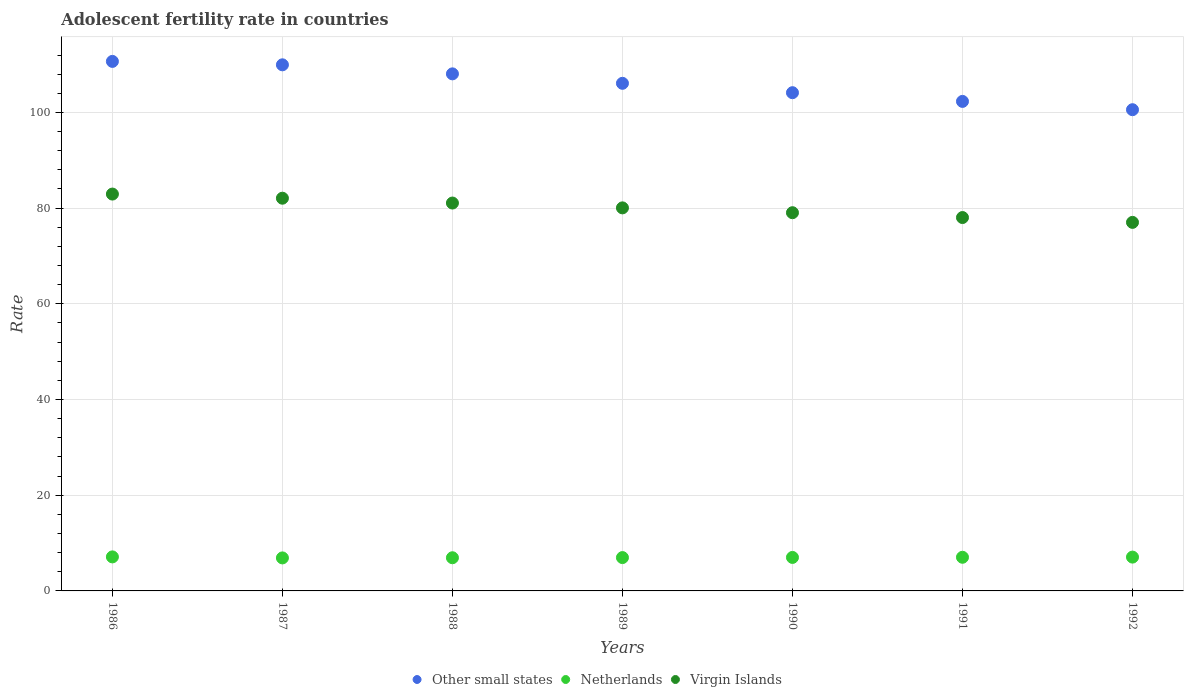How many different coloured dotlines are there?
Offer a very short reply. 3. What is the adolescent fertility rate in Netherlands in 1986?
Your answer should be compact. 7.11. Across all years, what is the maximum adolescent fertility rate in Other small states?
Offer a very short reply. 110.66. Across all years, what is the minimum adolescent fertility rate in Other small states?
Provide a short and direct response. 100.57. In which year was the adolescent fertility rate in Netherlands maximum?
Your answer should be very brief. 1986. What is the total adolescent fertility rate in Netherlands in the graph?
Provide a succinct answer. 49.01. What is the difference between the adolescent fertility rate in Netherlands in 1991 and that in 1992?
Offer a terse response. -0.03. What is the difference between the adolescent fertility rate in Other small states in 1991 and the adolescent fertility rate in Netherlands in 1986?
Your answer should be very brief. 95.19. What is the average adolescent fertility rate in Other small states per year?
Your answer should be very brief. 105.97. In the year 1991, what is the difference between the adolescent fertility rate in Virgin Islands and adolescent fertility rate in Other small states?
Keep it short and to the point. -24.27. What is the ratio of the adolescent fertility rate in Netherlands in 1986 to that in 1991?
Make the answer very short. 1.01. Is the adolescent fertility rate in Other small states in 1986 less than that in 1989?
Ensure brevity in your answer.  No. Is the difference between the adolescent fertility rate in Virgin Islands in 1987 and 1992 greater than the difference between the adolescent fertility rate in Other small states in 1987 and 1992?
Provide a short and direct response. No. What is the difference between the highest and the second highest adolescent fertility rate in Virgin Islands?
Offer a very short reply. 0.86. What is the difference between the highest and the lowest adolescent fertility rate in Virgin Islands?
Ensure brevity in your answer.  5.92. Is the sum of the adolescent fertility rate in Netherlands in 1988 and 1989 greater than the maximum adolescent fertility rate in Other small states across all years?
Keep it short and to the point. No. Is it the case that in every year, the sum of the adolescent fertility rate in Other small states and adolescent fertility rate in Virgin Islands  is greater than the adolescent fertility rate in Netherlands?
Give a very brief answer. Yes. Is the adolescent fertility rate in Netherlands strictly greater than the adolescent fertility rate in Other small states over the years?
Offer a very short reply. No. Is the adolescent fertility rate in Virgin Islands strictly less than the adolescent fertility rate in Netherlands over the years?
Provide a short and direct response. No. How many dotlines are there?
Offer a terse response. 3. How many years are there in the graph?
Your answer should be compact. 7. What is the difference between two consecutive major ticks on the Y-axis?
Offer a terse response. 20. Does the graph contain any zero values?
Your answer should be very brief. No. Does the graph contain grids?
Your answer should be very brief. Yes. How many legend labels are there?
Provide a succinct answer. 3. What is the title of the graph?
Your response must be concise. Adolescent fertility rate in countries. What is the label or title of the X-axis?
Give a very brief answer. Years. What is the label or title of the Y-axis?
Make the answer very short. Rate. What is the Rate in Other small states in 1986?
Your answer should be compact. 110.66. What is the Rate in Netherlands in 1986?
Provide a short and direct response. 7.11. What is the Rate in Virgin Islands in 1986?
Make the answer very short. 82.94. What is the Rate of Other small states in 1987?
Make the answer very short. 109.95. What is the Rate of Netherlands in 1987?
Your answer should be compact. 6.9. What is the Rate of Virgin Islands in 1987?
Make the answer very short. 82.07. What is the Rate in Other small states in 1988?
Keep it short and to the point. 108.06. What is the Rate in Netherlands in 1988?
Your answer should be compact. 6.93. What is the Rate of Virgin Islands in 1988?
Provide a short and direct response. 81.06. What is the Rate in Other small states in 1989?
Keep it short and to the point. 106.08. What is the Rate in Netherlands in 1989?
Offer a terse response. 6.97. What is the Rate of Virgin Islands in 1989?
Ensure brevity in your answer.  80.05. What is the Rate of Other small states in 1990?
Make the answer very short. 104.12. What is the Rate of Netherlands in 1990?
Your answer should be very brief. 7. What is the Rate of Virgin Islands in 1990?
Ensure brevity in your answer.  79.04. What is the Rate in Other small states in 1991?
Your answer should be very brief. 102.3. What is the Rate in Netherlands in 1991?
Your answer should be compact. 7.03. What is the Rate in Virgin Islands in 1991?
Keep it short and to the point. 78.03. What is the Rate of Other small states in 1992?
Provide a succinct answer. 100.57. What is the Rate of Netherlands in 1992?
Offer a terse response. 7.07. What is the Rate of Virgin Islands in 1992?
Offer a terse response. 77.02. Across all years, what is the maximum Rate in Other small states?
Your response must be concise. 110.66. Across all years, what is the maximum Rate in Netherlands?
Provide a short and direct response. 7.11. Across all years, what is the maximum Rate in Virgin Islands?
Give a very brief answer. 82.94. Across all years, what is the minimum Rate in Other small states?
Your answer should be compact. 100.57. Across all years, what is the minimum Rate of Netherlands?
Your answer should be compact. 6.9. Across all years, what is the minimum Rate of Virgin Islands?
Your answer should be compact. 77.02. What is the total Rate of Other small states in the graph?
Make the answer very short. 741.76. What is the total Rate in Netherlands in the graph?
Your answer should be compact. 49.01. What is the total Rate of Virgin Islands in the graph?
Give a very brief answer. 560.22. What is the difference between the Rate of Other small states in 1986 and that in 1987?
Provide a succinct answer. 0.71. What is the difference between the Rate of Netherlands in 1986 and that in 1987?
Your response must be concise. 0.21. What is the difference between the Rate in Virgin Islands in 1986 and that in 1987?
Make the answer very short. 0.86. What is the difference between the Rate in Other small states in 1986 and that in 1988?
Make the answer very short. 2.6. What is the difference between the Rate of Netherlands in 1986 and that in 1988?
Offer a very short reply. 0.18. What is the difference between the Rate in Virgin Islands in 1986 and that in 1988?
Your answer should be compact. 1.87. What is the difference between the Rate in Other small states in 1986 and that in 1989?
Offer a very short reply. 4.58. What is the difference between the Rate in Netherlands in 1986 and that in 1989?
Offer a very short reply. 0.14. What is the difference between the Rate in Virgin Islands in 1986 and that in 1989?
Provide a succinct answer. 2.89. What is the difference between the Rate of Other small states in 1986 and that in 1990?
Provide a succinct answer. 6.54. What is the difference between the Rate in Netherlands in 1986 and that in 1990?
Offer a very short reply. 0.11. What is the difference between the Rate in Virgin Islands in 1986 and that in 1990?
Offer a terse response. 3.9. What is the difference between the Rate of Other small states in 1986 and that in 1991?
Offer a terse response. 8.36. What is the difference between the Rate in Netherlands in 1986 and that in 1991?
Provide a succinct answer. 0.08. What is the difference between the Rate of Virgin Islands in 1986 and that in 1991?
Your response must be concise. 4.91. What is the difference between the Rate of Other small states in 1986 and that in 1992?
Provide a succinct answer. 10.09. What is the difference between the Rate in Netherlands in 1986 and that in 1992?
Your response must be concise. 0.04. What is the difference between the Rate in Virgin Islands in 1986 and that in 1992?
Give a very brief answer. 5.92. What is the difference between the Rate in Other small states in 1987 and that in 1988?
Your answer should be very brief. 1.89. What is the difference between the Rate in Netherlands in 1987 and that in 1988?
Offer a very short reply. -0.03. What is the difference between the Rate of Virgin Islands in 1987 and that in 1988?
Your answer should be compact. 1.01. What is the difference between the Rate of Other small states in 1987 and that in 1989?
Your answer should be compact. 3.87. What is the difference between the Rate of Netherlands in 1987 and that in 1989?
Ensure brevity in your answer.  -0.07. What is the difference between the Rate of Virgin Islands in 1987 and that in 1989?
Your answer should be compact. 2.02. What is the difference between the Rate in Other small states in 1987 and that in 1990?
Provide a succinct answer. 5.83. What is the difference between the Rate of Netherlands in 1987 and that in 1990?
Provide a succinct answer. -0.1. What is the difference between the Rate of Virgin Islands in 1987 and that in 1990?
Provide a short and direct response. 3.03. What is the difference between the Rate in Other small states in 1987 and that in 1991?
Ensure brevity in your answer.  7.65. What is the difference between the Rate in Netherlands in 1987 and that in 1991?
Give a very brief answer. -0.13. What is the difference between the Rate in Virgin Islands in 1987 and that in 1991?
Offer a very short reply. 4.04. What is the difference between the Rate of Other small states in 1987 and that in 1992?
Keep it short and to the point. 9.38. What is the difference between the Rate of Netherlands in 1987 and that in 1992?
Offer a terse response. -0.17. What is the difference between the Rate in Virgin Islands in 1987 and that in 1992?
Offer a terse response. 5.05. What is the difference between the Rate in Other small states in 1988 and that in 1989?
Give a very brief answer. 1.98. What is the difference between the Rate of Netherlands in 1988 and that in 1989?
Offer a very short reply. -0.03. What is the difference between the Rate of Virgin Islands in 1988 and that in 1989?
Your answer should be very brief. 1.01. What is the difference between the Rate in Other small states in 1988 and that in 1990?
Your answer should be very brief. 3.94. What is the difference between the Rate in Netherlands in 1988 and that in 1990?
Your answer should be very brief. -0.07. What is the difference between the Rate in Virgin Islands in 1988 and that in 1990?
Keep it short and to the point. 2.02. What is the difference between the Rate of Other small states in 1988 and that in 1991?
Your answer should be very brief. 5.76. What is the difference between the Rate in Netherlands in 1988 and that in 1991?
Give a very brief answer. -0.1. What is the difference between the Rate of Virgin Islands in 1988 and that in 1991?
Provide a succinct answer. 3.03. What is the difference between the Rate of Other small states in 1988 and that in 1992?
Give a very brief answer. 7.49. What is the difference between the Rate in Netherlands in 1988 and that in 1992?
Provide a short and direct response. -0.13. What is the difference between the Rate in Virgin Islands in 1988 and that in 1992?
Your answer should be very brief. 4.04. What is the difference between the Rate in Other small states in 1989 and that in 1990?
Keep it short and to the point. 1.96. What is the difference between the Rate in Netherlands in 1989 and that in 1990?
Provide a short and direct response. -0.03. What is the difference between the Rate of Virgin Islands in 1989 and that in 1990?
Provide a succinct answer. 1.01. What is the difference between the Rate in Other small states in 1989 and that in 1991?
Give a very brief answer. 3.78. What is the difference between the Rate of Netherlands in 1989 and that in 1991?
Provide a short and direct response. -0.07. What is the difference between the Rate of Virgin Islands in 1989 and that in 1991?
Keep it short and to the point. 2.02. What is the difference between the Rate in Other small states in 1989 and that in 1992?
Provide a short and direct response. 5.51. What is the difference between the Rate in Netherlands in 1989 and that in 1992?
Make the answer very short. -0.1. What is the difference between the Rate of Virgin Islands in 1989 and that in 1992?
Give a very brief answer. 3.03. What is the difference between the Rate of Other small states in 1990 and that in 1991?
Give a very brief answer. 1.82. What is the difference between the Rate in Netherlands in 1990 and that in 1991?
Offer a terse response. -0.03. What is the difference between the Rate in Virgin Islands in 1990 and that in 1991?
Your answer should be compact. 1.01. What is the difference between the Rate in Other small states in 1990 and that in 1992?
Provide a succinct answer. 3.55. What is the difference between the Rate in Netherlands in 1990 and that in 1992?
Offer a terse response. -0.07. What is the difference between the Rate of Virgin Islands in 1990 and that in 1992?
Provide a succinct answer. 2.02. What is the difference between the Rate in Other small states in 1991 and that in 1992?
Provide a succinct answer. 1.74. What is the difference between the Rate of Netherlands in 1991 and that in 1992?
Make the answer very short. -0.03. What is the difference between the Rate of Virgin Islands in 1991 and that in 1992?
Provide a short and direct response. 1.01. What is the difference between the Rate in Other small states in 1986 and the Rate in Netherlands in 1987?
Your answer should be compact. 103.76. What is the difference between the Rate of Other small states in 1986 and the Rate of Virgin Islands in 1987?
Provide a short and direct response. 28.59. What is the difference between the Rate in Netherlands in 1986 and the Rate in Virgin Islands in 1987?
Provide a succinct answer. -74.96. What is the difference between the Rate in Other small states in 1986 and the Rate in Netherlands in 1988?
Provide a succinct answer. 103.73. What is the difference between the Rate in Other small states in 1986 and the Rate in Virgin Islands in 1988?
Your answer should be very brief. 29.6. What is the difference between the Rate in Netherlands in 1986 and the Rate in Virgin Islands in 1988?
Your answer should be compact. -73.95. What is the difference between the Rate in Other small states in 1986 and the Rate in Netherlands in 1989?
Give a very brief answer. 103.7. What is the difference between the Rate of Other small states in 1986 and the Rate of Virgin Islands in 1989?
Your answer should be compact. 30.61. What is the difference between the Rate of Netherlands in 1986 and the Rate of Virgin Islands in 1989?
Your answer should be very brief. -72.94. What is the difference between the Rate in Other small states in 1986 and the Rate in Netherlands in 1990?
Provide a succinct answer. 103.66. What is the difference between the Rate of Other small states in 1986 and the Rate of Virgin Islands in 1990?
Give a very brief answer. 31.62. What is the difference between the Rate of Netherlands in 1986 and the Rate of Virgin Islands in 1990?
Keep it short and to the point. -71.93. What is the difference between the Rate in Other small states in 1986 and the Rate in Netherlands in 1991?
Ensure brevity in your answer.  103.63. What is the difference between the Rate in Other small states in 1986 and the Rate in Virgin Islands in 1991?
Ensure brevity in your answer.  32.63. What is the difference between the Rate of Netherlands in 1986 and the Rate of Virgin Islands in 1991?
Offer a terse response. -70.92. What is the difference between the Rate of Other small states in 1986 and the Rate of Netherlands in 1992?
Make the answer very short. 103.6. What is the difference between the Rate in Other small states in 1986 and the Rate in Virgin Islands in 1992?
Offer a terse response. 33.64. What is the difference between the Rate in Netherlands in 1986 and the Rate in Virgin Islands in 1992?
Provide a short and direct response. -69.91. What is the difference between the Rate in Other small states in 1987 and the Rate in Netherlands in 1988?
Your answer should be very brief. 103.02. What is the difference between the Rate in Other small states in 1987 and the Rate in Virgin Islands in 1988?
Provide a short and direct response. 28.89. What is the difference between the Rate of Netherlands in 1987 and the Rate of Virgin Islands in 1988?
Offer a very short reply. -74.16. What is the difference between the Rate of Other small states in 1987 and the Rate of Netherlands in 1989?
Provide a succinct answer. 102.98. What is the difference between the Rate in Other small states in 1987 and the Rate in Virgin Islands in 1989?
Offer a very short reply. 29.9. What is the difference between the Rate in Netherlands in 1987 and the Rate in Virgin Islands in 1989?
Offer a very short reply. -73.15. What is the difference between the Rate of Other small states in 1987 and the Rate of Netherlands in 1990?
Offer a very short reply. 102.95. What is the difference between the Rate of Other small states in 1987 and the Rate of Virgin Islands in 1990?
Ensure brevity in your answer.  30.91. What is the difference between the Rate in Netherlands in 1987 and the Rate in Virgin Islands in 1990?
Offer a terse response. -72.14. What is the difference between the Rate in Other small states in 1987 and the Rate in Netherlands in 1991?
Your answer should be very brief. 102.92. What is the difference between the Rate in Other small states in 1987 and the Rate in Virgin Islands in 1991?
Your response must be concise. 31.92. What is the difference between the Rate of Netherlands in 1987 and the Rate of Virgin Islands in 1991?
Your response must be concise. -71.13. What is the difference between the Rate in Other small states in 1987 and the Rate in Netherlands in 1992?
Your answer should be compact. 102.88. What is the difference between the Rate in Other small states in 1987 and the Rate in Virgin Islands in 1992?
Make the answer very short. 32.93. What is the difference between the Rate in Netherlands in 1987 and the Rate in Virgin Islands in 1992?
Provide a succinct answer. -70.12. What is the difference between the Rate of Other small states in 1988 and the Rate of Netherlands in 1989?
Your response must be concise. 101.09. What is the difference between the Rate of Other small states in 1988 and the Rate of Virgin Islands in 1989?
Your answer should be compact. 28.01. What is the difference between the Rate of Netherlands in 1988 and the Rate of Virgin Islands in 1989?
Your response must be concise. -73.12. What is the difference between the Rate of Other small states in 1988 and the Rate of Netherlands in 1990?
Your answer should be very brief. 101.06. What is the difference between the Rate of Other small states in 1988 and the Rate of Virgin Islands in 1990?
Your answer should be compact. 29.02. What is the difference between the Rate in Netherlands in 1988 and the Rate in Virgin Islands in 1990?
Your response must be concise. -72.11. What is the difference between the Rate in Other small states in 1988 and the Rate in Netherlands in 1991?
Provide a succinct answer. 101.03. What is the difference between the Rate of Other small states in 1988 and the Rate of Virgin Islands in 1991?
Your answer should be compact. 30.03. What is the difference between the Rate in Netherlands in 1988 and the Rate in Virgin Islands in 1991?
Your response must be concise. -71.1. What is the difference between the Rate in Other small states in 1988 and the Rate in Netherlands in 1992?
Ensure brevity in your answer.  100.99. What is the difference between the Rate in Other small states in 1988 and the Rate in Virgin Islands in 1992?
Offer a very short reply. 31.04. What is the difference between the Rate of Netherlands in 1988 and the Rate of Virgin Islands in 1992?
Provide a short and direct response. -70.09. What is the difference between the Rate in Other small states in 1989 and the Rate in Netherlands in 1990?
Give a very brief answer. 99.08. What is the difference between the Rate of Other small states in 1989 and the Rate of Virgin Islands in 1990?
Provide a succinct answer. 27.04. What is the difference between the Rate in Netherlands in 1989 and the Rate in Virgin Islands in 1990?
Ensure brevity in your answer.  -72.08. What is the difference between the Rate in Other small states in 1989 and the Rate in Netherlands in 1991?
Give a very brief answer. 99.05. What is the difference between the Rate in Other small states in 1989 and the Rate in Virgin Islands in 1991?
Your answer should be very brief. 28.05. What is the difference between the Rate in Netherlands in 1989 and the Rate in Virgin Islands in 1991?
Ensure brevity in your answer.  -71.07. What is the difference between the Rate of Other small states in 1989 and the Rate of Netherlands in 1992?
Your answer should be compact. 99.02. What is the difference between the Rate in Other small states in 1989 and the Rate in Virgin Islands in 1992?
Give a very brief answer. 29.06. What is the difference between the Rate in Netherlands in 1989 and the Rate in Virgin Islands in 1992?
Offer a very short reply. -70.05. What is the difference between the Rate in Other small states in 1990 and the Rate in Netherlands in 1991?
Offer a very short reply. 97.09. What is the difference between the Rate in Other small states in 1990 and the Rate in Virgin Islands in 1991?
Provide a short and direct response. 26.09. What is the difference between the Rate of Netherlands in 1990 and the Rate of Virgin Islands in 1991?
Provide a succinct answer. -71.03. What is the difference between the Rate in Other small states in 1990 and the Rate in Netherlands in 1992?
Your answer should be very brief. 97.06. What is the difference between the Rate of Other small states in 1990 and the Rate of Virgin Islands in 1992?
Offer a very short reply. 27.1. What is the difference between the Rate of Netherlands in 1990 and the Rate of Virgin Islands in 1992?
Offer a terse response. -70.02. What is the difference between the Rate of Other small states in 1991 and the Rate of Netherlands in 1992?
Give a very brief answer. 95.24. What is the difference between the Rate of Other small states in 1991 and the Rate of Virgin Islands in 1992?
Keep it short and to the point. 25.28. What is the difference between the Rate in Netherlands in 1991 and the Rate in Virgin Islands in 1992?
Your answer should be very brief. -69.99. What is the average Rate in Other small states per year?
Give a very brief answer. 105.97. What is the average Rate of Netherlands per year?
Your response must be concise. 7. What is the average Rate of Virgin Islands per year?
Provide a succinct answer. 80.03. In the year 1986, what is the difference between the Rate in Other small states and Rate in Netherlands?
Offer a very short reply. 103.55. In the year 1986, what is the difference between the Rate of Other small states and Rate of Virgin Islands?
Your response must be concise. 27.73. In the year 1986, what is the difference between the Rate of Netherlands and Rate of Virgin Islands?
Give a very brief answer. -75.83. In the year 1987, what is the difference between the Rate of Other small states and Rate of Netherlands?
Offer a terse response. 103.05. In the year 1987, what is the difference between the Rate of Other small states and Rate of Virgin Islands?
Offer a very short reply. 27.88. In the year 1987, what is the difference between the Rate in Netherlands and Rate in Virgin Islands?
Your answer should be very brief. -75.17. In the year 1988, what is the difference between the Rate in Other small states and Rate in Netherlands?
Keep it short and to the point. 101.13. In the year 1988, what is the difference between the Rate of Other small states and Rate of Virgin Islands?
Give a very brief answer. 27. In the year 1988, what is the difference between the Rate in Netherlands and Rate in Virgin Islands?
Your answer should be compact. -74.13. In the year 1989, what is the difference between the Rate in Other small states and Rate in Netherlands?
Your answer should be compact. 99.12. In the year 1989, what is the difference between the Rate in Other small states and Rate in Virgin Islands?
Your answer should be compact. 26.03. In the year 1989, what is the difference between the Rate of Netherlands and Rate of Virgin Islands?
Give a very brief answer. -73.09. In the year 1990, what is the difference between the Rate of Other small states and Rate of Netherlands?
Offer a terse response. 97.12. In the year 1990, what is the difference between the Rate in Other small states and Rate in Virgin Islands?
Ensure brevity in your answer.  25.08. In the year 1990, what is the difference between the Rate of Netherlands and Rate of Virgin Islands?
Your answer should be compact. -72.04. In the year 1991, what is the difference between the Rate of Other small states and Rate of Netherlands?
Provide a succinct answer. 95.27. In the year 1991, what is the difference between the Rate in Other small states and Rate in Virgin Islands?
Provide a short and direct response. 24.27. In the year 1991, what is the difference between the Rate in Netherlands and Rate in Virgin Islands?
Your answer should be compact. -71. In the year 1992, what is the difference between the Rate of Other small states and Rate of Netherlands?
Offer a very short reply. 93.5. In the year 1992, what is the difference between the Rate of Other small states and Rate of Virgin Islands?
Provide a succinct answer. 23.55. In the year 1992, what is the difference between the Rate in Netherlands and Rate in Virgin Islands?
Your response must be concise. -69.95. What is the ratio of the Rate of Other small states in 1986 to that in 1987?
Offer a terse response. 1.01. What is the ratio of the Rate in Netherlands in 1986 to that in 1987?
Give a very brief answer. 1.03. What is the ratio of the Rate in Virgin Islands in 1986 to that in 1987?
Make the answer very short. 1.01. What is the ratio of the Rate of Other small states in 1986 to that in 1988?
Offer a terse response. 1.02. What is the ratio of the Rate of Netherlands in 1986 to that in 1988?
Keep it short and to the point. 1.03. What is the ratio of the Rate of Virgin Islands in 1986 to that in 1988?
Provide a short and direct response. 1.02. What is the ratio of the Rate in Other small states in 1986 to that in 1989?
Give a very brief answer. 1.04. What is the ratio of the Rate in Netherlands in 1986 to that in 1989?
Your answer should be very brief. 1.02. What is the ratio of the Rate in Virgin Islands in 1986 to that in 1989?
Your answer should be compact. 1.04. What is the ratio of the Rate in Other small states in 1986 to that in 1990?
Your answer should be compact. 1.06. What is the ratio of the Rate of Netherlands in 1986 to that in 1990?
Offer a very short reply. 1.02. What is the ratio of the Rate of Virgin Islands in 1986 to that in 1990?
Keep it short and to the point. 1.05. What is the ratio of the Rate of Other small states in 1986 to that in 1991?
Make the answer very short. 1.08. What is the ratio of the Rate of Virgin Islands in 1986 to that in 1991?
Offer a very short reply. 1.06. What is the ratio of the Rate in Other small states in 1986 to that in 1992?
Keep it short and to the point. 1.1. What is the ratio of the Rate of Virgin Islands in 1986 to that in 1992?
Your response must be concise. 1.08. What is the ratio of the Rate of Other small states in 1987 to that in 1988?
Your answer should be very brief. 1.02. What is the ratio of the Rate in Netherlands in 1987 to that in 1988?
Make the answer very short. 1. What is the ratio of the Rate in Virgin Islands in 1987 to that in 1988?
Offer a terse response. 1.01. What is the ratio of the Rate in Other small states in 1987 to that in 1989?
Offer a terse response. 1.04. What is the ratio of the Rate of Virgin Islands in 1987 to that in 1989?
Give a very brief answer. 1.03. What is the ratio of the Rate of Other small states in 1987 to that in 1990?
Your answer should be compact. 1.06. What is the ratio of the Rate in Netherlands in 1987 to that in 1990?
Give a very brief answer. 0.99. What is the ratio of the Rate in Virgin Islands in 1987 to that in 1990?
Give a very brief answer. 1.04. What is the ratio of the Rate of Other small states in 1987 to that in 1991?
Offer a very short reply. 1.07. What is the ratio of the Rate of Netherlands in 1987 to that in 1991?
Offer a terse response. 0.98. What is the ratio of the Rate of Virgin Islands in 1987 to that in 1991?
Provide a succinct answer. 1.05. What is the ratio of the Rate in Other small states in 1987 to that in 1992?
Give a very brief answer. 1.09. What is the ratio of the Rate in Netherlands in 1987 to that in 1992?
Offer a very short reply. 0.98. What is the ratio of the Rate in Virgin Islands in 1987 to that in 1992?
Keep it short and to the point. 1.07. What is the ratio of the Rate of Other small states in 1988 to that in 1989?
Give a very brief answer. 1.02. What is the ratio of the Rate in Virgin Islands in 1988 to that in 1989?
Your answer should be compact. 1.01. What is the ratio of the Rate of Other small states in 1988 to that in 1990?
Provide a short and direct response. 1.04. What is the ratio of the Rate of Netherlands in 1988 to that in 1990?
Provide a short and direct response. 0.99. What is the ratio of the Rate in Virgin Islands in 1988 to that in 1990?
Your answer should be compact. 1.03. What is the ratio of the Rate of Other small states in 1988 to that in 1991?
Your answer should be very brief. 1.06. What is the ratio of the Rate in Netherlands in 1988 to that in 1991?
Provide a succinct answer. 0.99. What is the ratio of the Rate of Virgin Islands in 1988 to that in 1991?
Provide a short and direct response. 1.04. What is the ratio of the Rate of Other small states in 1988 to that in 1992?
Provide a short and direct response. 1.07. What is the ratio of the Rate in Virgin Islands in 1988 to that in 1992?
Your answer should be very brief. 1.05. What is the ratio of the Rate in Other small states in 1989 to that in 1990?
Your response must be concise. 1.02. What is the ratio of the Rate of Virgin Islands in 1989 to that in 1990?
Offer a terse response. 1.01. What is the ratio of the Rate of Other small states in 1989 to that in 1991?
Your response must be concise. 1.04. What is the ratio of the Rate in Virgin Islands in 1989 to that in 1991?
Offer a very short reply. 1.03. What is the ratio of the Rate in Other small states in 1989 to that in 1992?
Ensure brevity in your answer.  1.05. What is the ratio of the Rate of Netherlands in 1989 to that in 1992?
Ensure brevity in your answer.  0.99. What is the ratio of the Rate of Virgin Islands in 1989 to that in 1992?
Make the answer very short. 1.04. What is the ratio of the Rate of Other small states in 1990 to that in 1991?
Keep it short and to the point. 1.02. What is the ratio of the Rate of Netherlands in 1990 to that in 1991?
Your answer should be compact. 1. What is the ratio of the Rate in Virgin Islands in 1990 to that in 1991?
Keep it short and to the point. 1.01. What is the ratio of the Rate in Other small states in 1990 to that in 1992?
Offer a very short reply. 1.04. What is the ratio of the Rate in Netherlands in 1990 to that in 1992?
Give a very brief answer. 0.99. What is the ratio of the Rate in Virgin Islands in 1990 to that in 1992?
Provide a succinct answer. 1.03. What is the ratio of the Rate of Other small states in 1991 to that in 1992?
Offer a very short reply. 1.02. What is the ratio of the Rate in Virgin Islands in 1991 to that in 1992?
Your answer should be compact. 1.01. What is the difference between the highest and the second highest Rate in Other small states?
Your response must be concise. 0.71. What is the difference between the highest and the second highest Rate of Netherlands?
Make the answer very short. 0.04. What is the difference between the highest and the second highest Rate of Virgin Islands?
Your response must be concise. 0.86. What is the difference between the highest and the lowest Rate in Other small states?
Your answer should be very brief. 10.09. What is the difference between the highest and the lowest Rate in Netherlands?
Your answer should be compact. 0.21. What is the difference between the highest and the lowest Rate in Virgin Islands?
Provide a succinct answer. 5.92. 